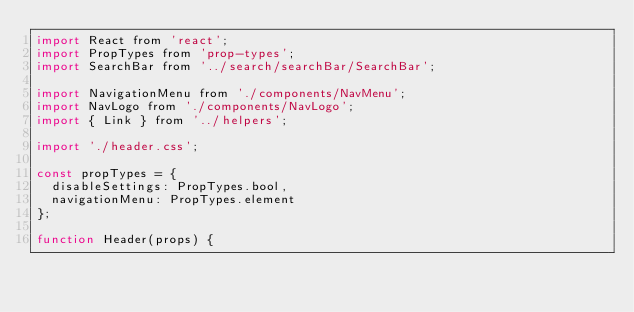Convert code to text. <code><loc_0><loc_0><loc_500><loc_500><_JavaScript_>import React from 'react';
import PropTypes from 'prop-types';
import SearchBar from '../search/searchBar/SearchBar';

import NavigationMenu from './components/NavMenu';
import NavLogo from './components/NavLogo';
import { Link } from '../helpers';

import './header.css';

const propTypes = {
  disableSettings: PropTypes.bool,
  navigationMenu: PropTypes.element
};

function Header(props) {</code> 